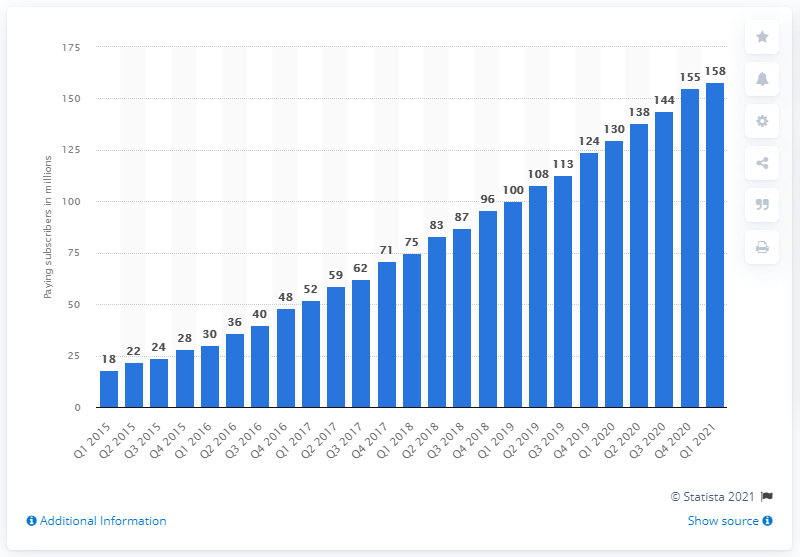Give some essential details in this illustration. In the first quarter of 2021, Spotify had 158 paid subscribers. In the quarter of 2020, Spotify had a total of 130 paid subscribers. 